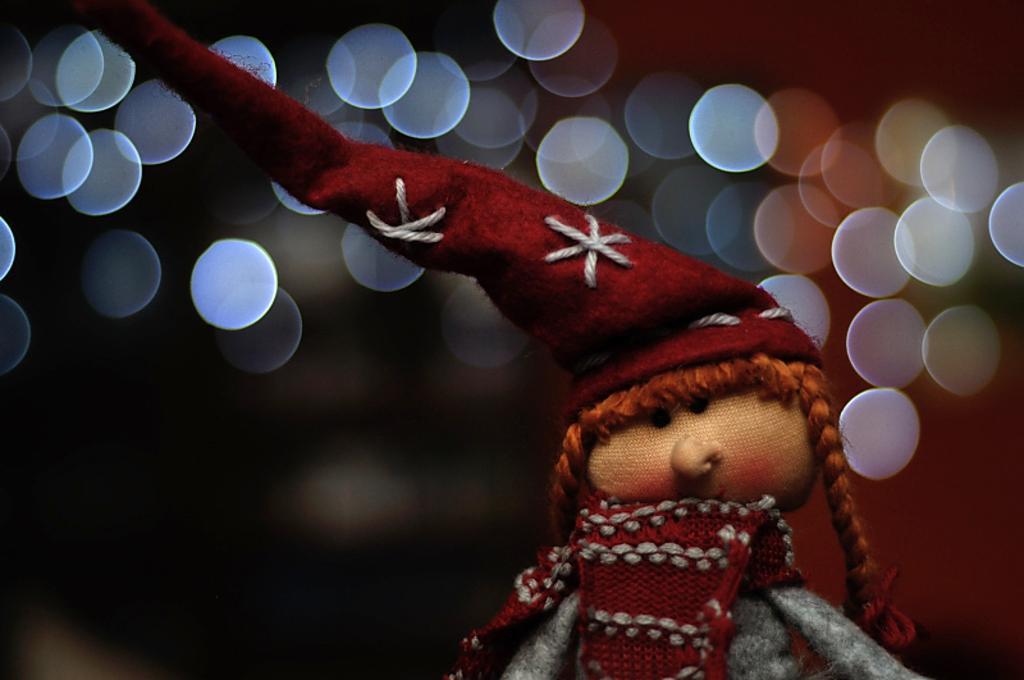Could you give a brief overview of what you see in this image? In this picture I can see there is a doll and there is a a red color cap and in the backdrop I can see there are lights. 